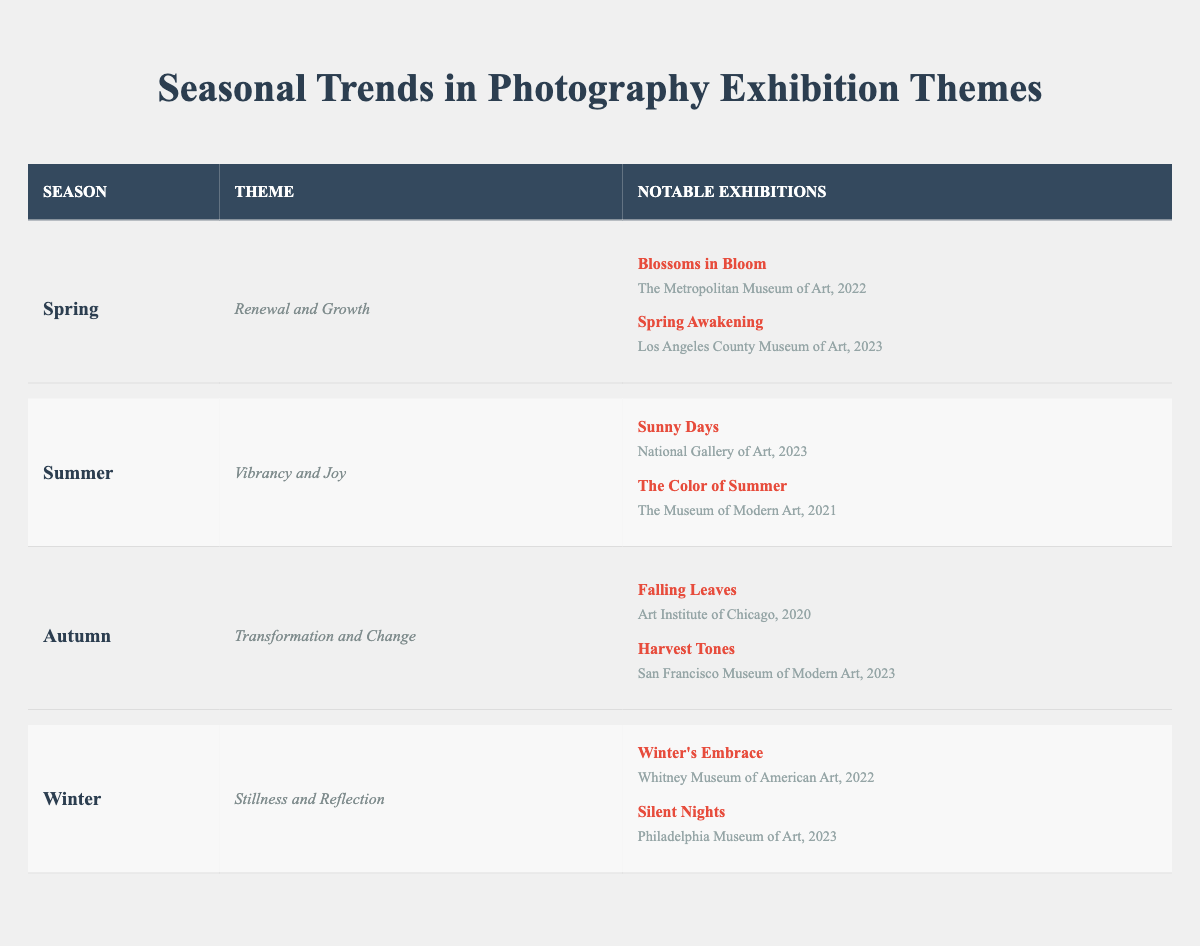What is the theme for the Winter season? The table explicitly lists the theme associated with each season. For Winter, the theme is clearly shown as "Stillness and Reflection."
Answer: Stillness and Reflection Which exhibition took place at The Museum of Modern Art in 2021? By scanning the table, I can look at the exhibitions listed for each season. For summer, "The Color of Summer" is the exhibition that occurred at The Museum of Modern Art in 2021.
Answer: The Color of Summer How many notable exhibitions are listed for Spring? The table displays the number of exhibitions under each season. For Spring, there are two notable exhibitions: "Blossoms in Bloom" and "Spring Awakening." Thus, the total count is two.
Answer: 2 Did the Art Institute of Chicago host an exhibition in 2023? Looking at the Autumn section, "Falling Leaves" was held in 2020 at the Art Institute of Chicago. However, there is no exhibition hosted there in 2023, confirming a no answer.
Answer: No Which season has the theme of "Transformation and Change"? Checking the table, the theme "Transformation and Change" is associated with the Autumn season, which is clearly stated in the entry for that season.
Answer: Autumn How many exhibitions occurred in 2023? I need to review all the notable exhibitions across the seasons and count those from 2023. In Spring, there is "Spring Awakening," in Summer, "Sunny Days," in Autumn, "Harvest Tones," and in Winter, "Silent Nights." This totals four exhibitions for the year 2023.
Answer: 4 Which notable exhibition took place at the National Gallery of Art? The data specifies that "Sunny Days" is the notable exhibition at the National Gallery of Art under the Summer theme.
Answer: Sunny Days Compare the themes of Summer and Winter; are they opposites? Summer has the theme "Vibrancy and Joy," while Winter features "Stillness and Reflection." To determine if they are opposites, I consider that vibrancy and joy suggest activity and brightness, contrasting with stillness and reflection, which imply calm and contemplation. Therefore, they can be interpreted as opposites.
Answer: Yes How many exhibitions focused on nature themes in 2022? The table highlights the notable exhibitions in 2022. For nature themes, both "Blossoms in Bloom" (Spring) and "Winter's Embrace" (Winter) can be categorized as relating to nature. Thus, there are two exhibitions focused on nature themes in that year.
Answer: 2 